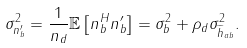<formula> <loc_0><loc_0><loc_500><loc_500>\sigma _ { n _ { b } ^ { \prime } } ^ { 2 } = \frac { 1 } { n _ { d } } \mathbb { E } \left [ n _ { b } ^ { H } n _ { b } ^ { \prime } \right ] = \sigma _ { b } ^ { 2 } + \rho _ { d } \sigma _ { \widetilde { h } _ { a b } } ^ { 2 } .</formula> 